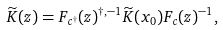Convert formula to latex. <formula><loc_0><loc_0><loc_500><loc_500>\widetilde { K } ( z ) = F _ { c ^ { \dagger } } ( z ) ^ { \dagger , - 1 } \widetilde { K } ( x _ { 0 } ) F _ { c } ( z ) ^ { - 1 } ,</formula> 